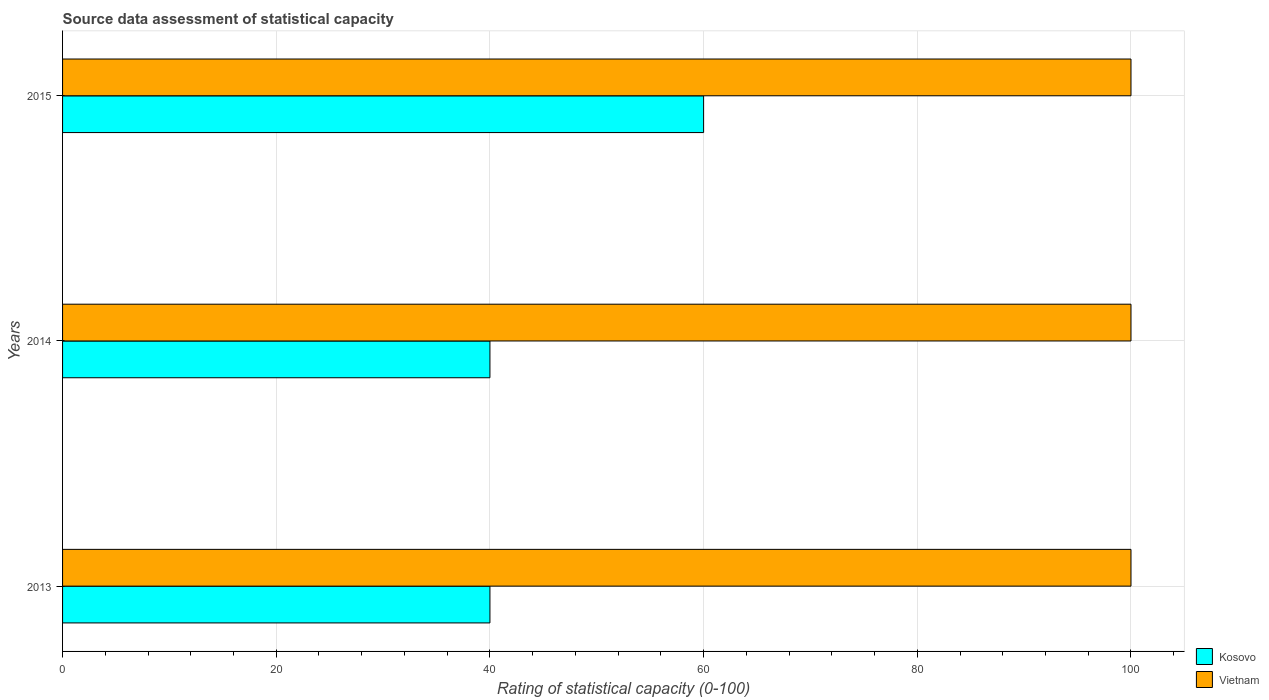How many different coloured bars are there?
Your response must be concise. 2. How many groups of bars are there?
Give a very brief answer. 3. How many bars are there on the 2nd tick from the top?
Give a very brief answer. 2. In how many cases, is the number of bars for a given year not equal to the number of legend labels?
Provide a short and direct response. 0. What is the rating of statistical capacity in Kosovo in 2015?
Your answer should be very brief. 60. Across all years, what is the maximum rating of statistical capacity in Vietnam?
Give a very brief answer. 100. Across all years, what is the minimum rating of statistical capacity in Vietnam?
Ensure brevity in your answer.  100. In which year was the rating of statistical capacity in Kosovo minimum?
Offer a terse response. 2013. What is the total rating of statistical capacity in Kosovo in the graph?
Give a very brief answer. 140. What is the difference between the rating of statistical capacity in Vietnam in 2013 and the rating of statistical capacity in Kosovo in 2015?
Your answer should be very brief. 40. What is the average rating of statistical capacity in Kosovo per year?
Give a very brief answer. 46.67. In the year 2014, what is the difference between the rating of statistical capacity in Vietnam and rating of statistical capacity in Kosovo?
Your answer should be very brief. 60. In how many years, is the rating of statistical capacity in Kosovo greater than 64 ?
Your answer should be very brief. 0. What is the ratio of the rating of statistical capacity in Vietnam in 2013 to that in 2015?
Offer a very short reply. 1. Is the difference between the rating of statistical capacity in Vietnam in 2013 and 2015 greater than the difference between the rating of statistical capacity in Kosovo in 2013 and 2015?
Offer a terse response. Yes. What is the difference between the highest and the lowest rating of statistical capacity in Vietnam?
Offer a very short reply. 0. What does the 1st bar from the top in 2013 represents?
Provide a succinct answer. Vietnam. What does the 2nd bar from the bottom in 2015 represents?
Make the answer very short. Vietnam. How many bars are there?
Offer a very short reply. 6. Are all the bars in the graph horizontal?
Offer a terse response. Yes. What is the title of the graph?
Provide a succinct answer. Source data assessment of statistical capacity. Does "Guyana" appear as one of the legend labels in the graph?
Provide a short and direct response. No. What is the label or title of the X-axis?
Give a very brief answer. Rating of statistical capacity (0-100). What is the Rating of statistical capacity (0-100) in Kosovo in 2013?
Provide a short and direct response. 40. What is the Rating of statistical capacity (0-100) in Kosovo in 2014?
Make the answer very short. 40. What is the Rating of statistical capacity (0-100) of Kosovo in 2015?
Give a very brief answer. 60. Across all years, what is the minimum Rating of statistical capacity (0-100) in Vietnam?
Your answer should be compact. 100. What is the total Rating of statistical capacity (0-100) in Kosovo in the graph?
Give a very brief answer. 140. What is the total Rating of statistical capacity (0-100) of Vietnam in the graph?
Offer a terse response. 300. What is the difference between the Rating of statistical capacity (0-100) in Kosovo in 2014 and that in 2015?
Give a very brief answer. -20. What is the difference between the Rating of statistical capacity (0-100) in Vietnam in 2014 and that in 2015?
Keep it short and to the point. 0. What is the difference between the Rating of statistical capacity (0-100) of Kosovo in 2013 and the Rating of statistical capacity (0-100) of Vietnam in 2014?
Ensure brevity in your answer.  -60. What is the difference between the Rating of statistical capacity (0-100) in Kosovo in 2013 and the Rating of statistical capacity (0-100) in Vietnam in 2015?
Your response must be concise. -60. What is the difference between the Rating of statistical capacity (0-100) of Kosovo in 2014 and the Rating of statistical capacity (0-100) of Vietnam in 2015?
Your answer should be very brief. -60. What is the average Rating of statistical capacity (0-100) of Kosovo per year?
Give a very brief answer. 46.67. In the year 2013, what is the difference between the Rating of statistical capacity (0-100) in Kosovo and Rating of statistical capacity (0-100) in Vietnam?
Provide a short and direct response. -60. In the year 2014, what is the difference between the Rating of statistical capacity (0-100) of Kosovo and Rating of statistical capacity (0-100) of Vietnam?
Give a very brief answer. -60. What is the ratio of the Rating of statistical capacity (0-100) in Vietnam in 2013 to that in 2014?
Your answer should be very brief. 1. What is the ratio of the Rating of statistical capacity (0-100) of Vietnam in 2013 to that in 2015?
Your answer should be very brief. 1. What is the difference between the highest and the lowest Rating of statistical capacity (0-100) in Vietnam?
Keep it short and to the point. 0. 